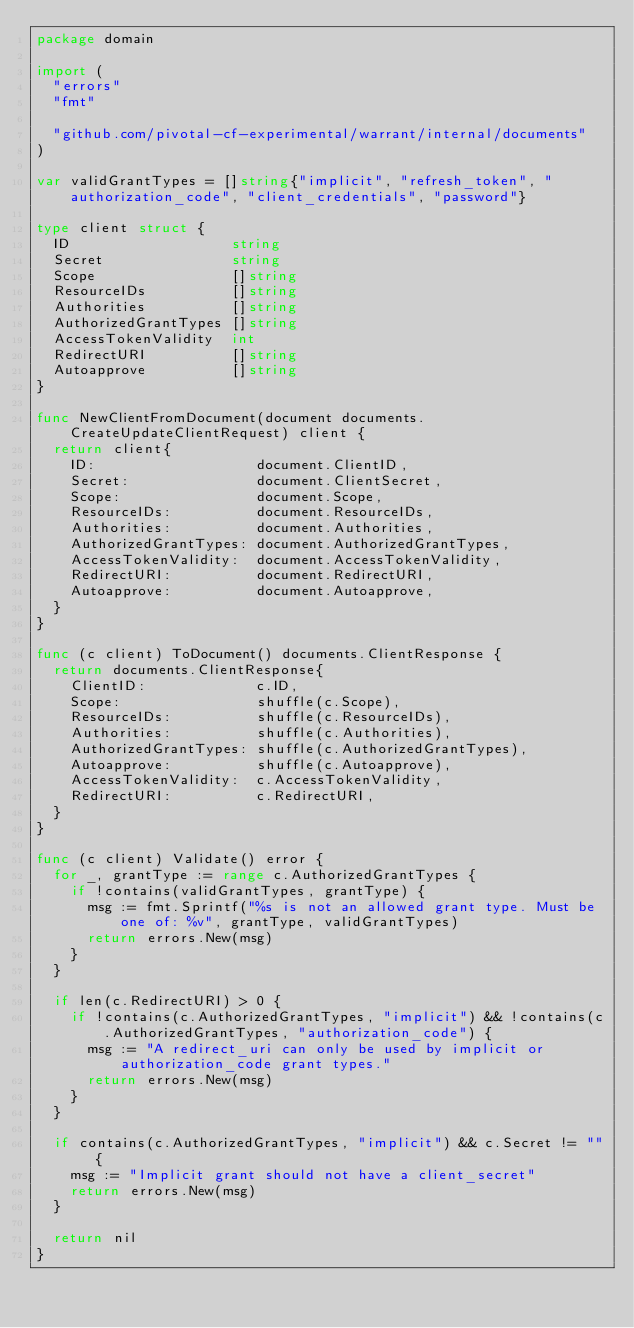Convert code to text. <code><loc_0><loc_0><loc_500><loc_500><_Go_>package domain

import (
	"errors"
	"fmt"

	"github.com/pivotal-cf-experimental/warrant/internal/documents"
)

var validGrantTypes = []string{"implicit", "refresh_token", "authorization_code", "client_credentials", "password"}

type client struct {
	ID                   string
	Secret               string
	Scope                []string
	ResourceIDs          []string
	Authorities          []string
	AuthorizedGrantTypes []string
	AccessTokenValidity  int
	RedirectURI          []string
	Autoapprove          []string
}

func NewClientFromDocument(document documents.CreateUpdateClientRequest) client {
	return client{
		ID:                   document.ClientID,
		Secret:               document.ClientSecret,
		Scope:                document.Scope,
		ResourceIDs:          document.ResourceIDs,
		Authorities:          document.Authorities,
		AuthorizedGrantTypes: document.AuthorizedGrantTypes,
		AccessTokenValidity:  document.AccessTokenValidity,
		RedirectURI:          document.RedirectURI,
		Autoapprove:          document.Autoapprove,
	}
}

func (c client) ToDocument() documents.ClientResponse {
	return documents.ClientResponse{
		ClientID:             c.ID,
		Scope:                shuffle(c.Scope),
		ResourceIDs:          shuffle(c.ResourceIDs),
		Authorities:          shuffle(c.Authorities),
		AuthorizedGrantTypes: shuffle(c.AuthorizedGrantTypes),
		Autoapprove:          shuffle(c.Autoapprove),
		AccessTokenValidity:  c.AccessTokenValidity,
		RedirectURI:          c.RedirectURI,
	}
}

func (c client) Validate() error {
	for _, grantType := range c.AuthorizedGrantTypes {
		if !contains(validGrantTypes, grantType) {
			msg := fmt.Sprintf("%s is not an allowed grant type. Must be one of: %v", grantType, validGrantTypes)
			return errors.New(msg)
		}
	}

	if len(c.RedirectURI) > 0 {
		if !contains(c.AuthorizedGrantTypes, "implicit") && !contains(c.AuthorizedGrantTypes, "authorization_code") {
			msg := "A redirect_uri can only be used by implicit or authorization_code grant types."
			return errors.New(msg)
		}
	}

	if contains(c.AuthorizedGrantTypes, "implicit") && c.Secret != "" {
		msg := "Implicit grant should not have a client_secret"
		return errors.New(msg)
	}

	return nil
}
</code> 